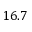<formula> <loc_0><loc_0><loc_500><loc_500>1 6 . 7</formula> 